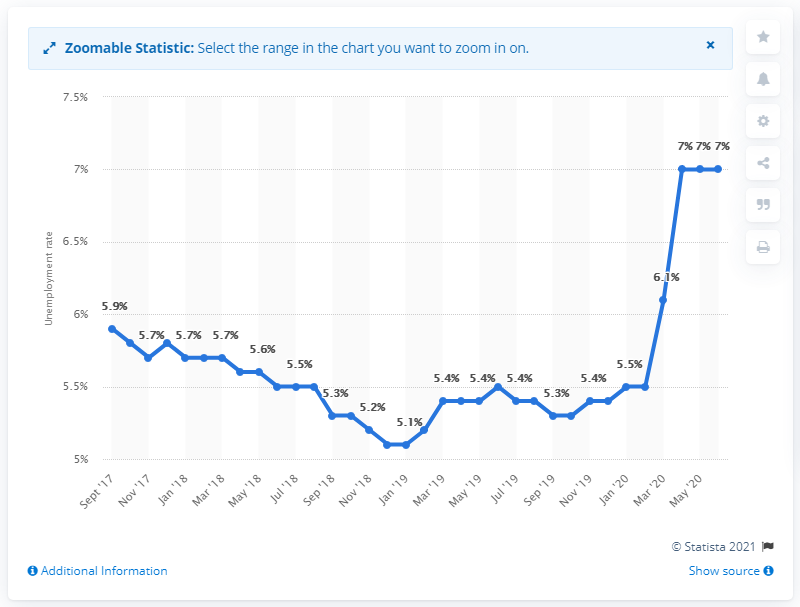What is the unemployment rate in Luxembourg expected to decrease to in 2021? According to the data from the provided chart, the unemployment rate in Luxembourg is not expected to decrease in 2021; rather, it shows a sharp increase to 7%. 